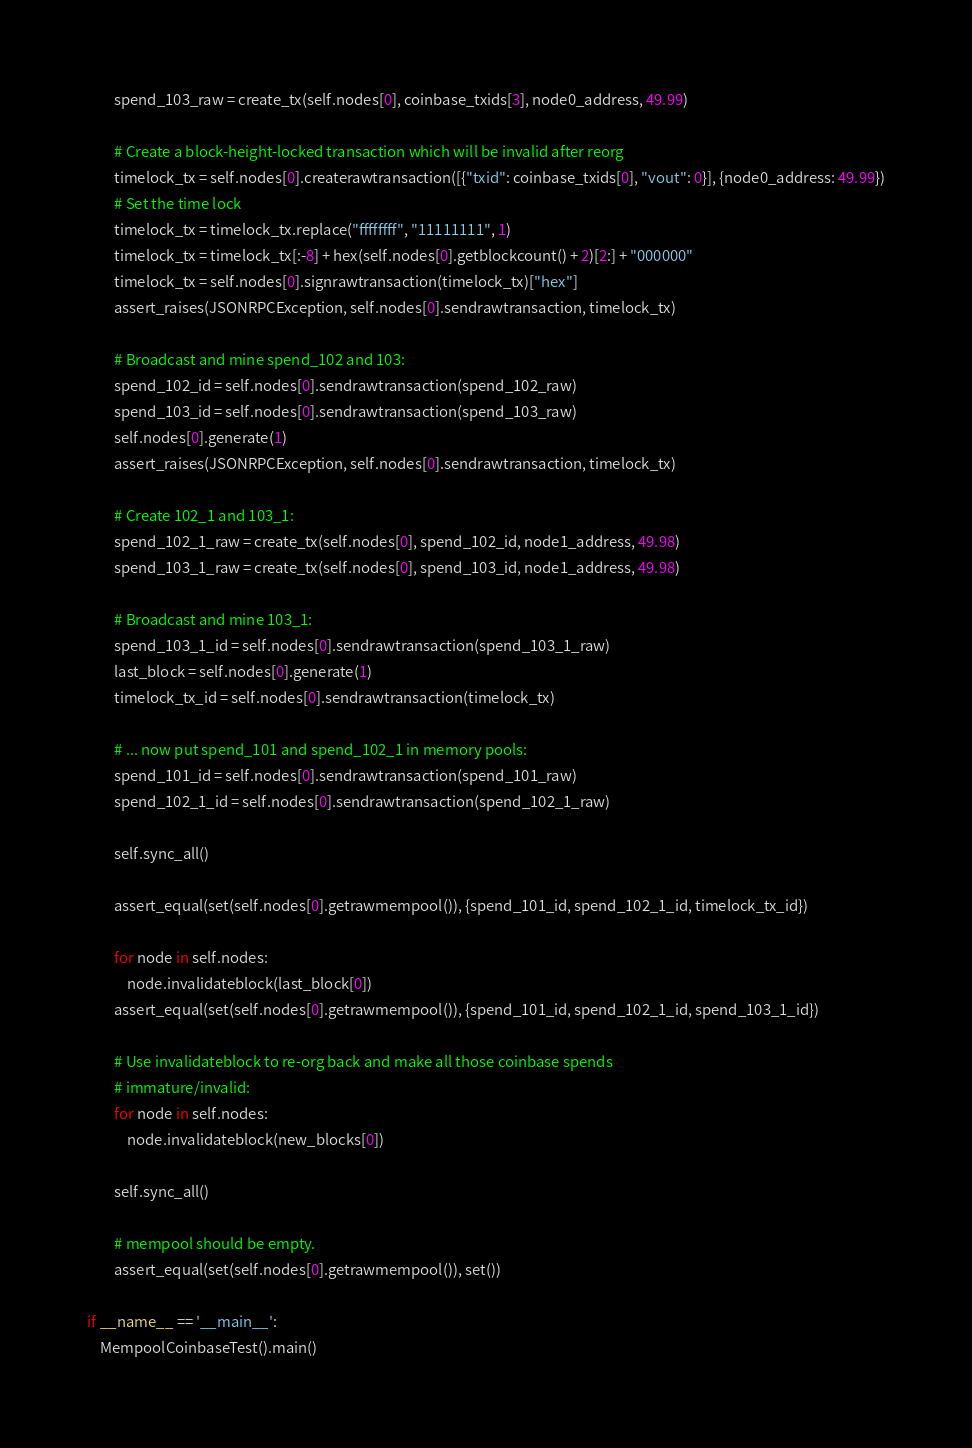<code> <loc_0><loc_0><loc_500><loc_500><_Python_>        spend_103_raw = create_tx(self.nodes[0], coinbase_txids[3], node0_address, 49.99)

        # Create a block-height-locked transaction which will be invalid after reorg
        timelock_tx = self.nodes[0].createrawtransaction([{"txid": coinbase_txids[0], "vout": 0}], {node0_address: 49.99})
        # Set the time lock
        timelock_tx = timelock_tx.replace("ffffffff", "11111111", 1)
        timelock_tx = timelock_tx[:-8] + hex(self.nodes[0].getblockcount() + 2)[2:] + "000000"
        timelock_tx = self.nodes[0].signrawtransaction(timelock_tx)["hex"]
        assert_raises(JSONRPCException, self.nodes[0].sendrawtransaction, timelock_tx)

        # Broadcast and mine spend_102 and 103:
        spend_102_id = self.nodes[0].sendrawtransaction(spend_102_raw)
        spend_103_id = self.nodes[0].sendrawtransaction(spend_103_raw)
        self.nodes[0].generate(1)
        assert_raises(JSONRPCException, self.nodes[0].sendrawtransaction, timelock_tx)

        # Create 102_1 and 103_1:
        spend_102_1_raw = create_tx(self.nodes[0], spend_102_id, node1_address, 49.98)
        spend_103_1_raw = create_tx(self.nodes[0], spend_103_id, node1_address, 49.98)

        # Broadcast and mine 103_1:
        spend_103_1_id = self.nodes[0].sendrawtransaction(spend_103_1_raw)
        last_block = self.nodes[0].generate(1)
        timelock_tx_id = self.nodes[0].sendrawtransaction(timelock_tx)

        # ... now put spend_101 and spend_102_1 in memory pools:
        spend_101_id = self.nodes[0].sendrawtransaction(spend_101_raw)
        spend_102_1_id = self.nodes[0].sendrawtransaction(spend_102_1_raw)

        self.sync_all()

        assert_equal(set(self.nodes[0].getrawmempool()), {spend_101_id, spend_102_1_id, timelock_tx_id})

        for node in self.nodes:
            node.invalidateblock(last_block[0])
        assert_equal(set(self.nodes[0].getrawmempool()), {spend_101_id, spend_102_1_id, spend_103_1_id})

        # Use invalidateblock to re-org back and make all those coinbase spends
        # immature/invalid:
        for node in self.nodes:
            node.invalidateblock(new_blocks[0])

        self.sync_all()

        # mempool should be empty.
        assert_equal(set(self.nodes[0].getrawmempool()), set())

if __name__ == '__main__':
    MempoolCoinbaseTest().main()
</code> 